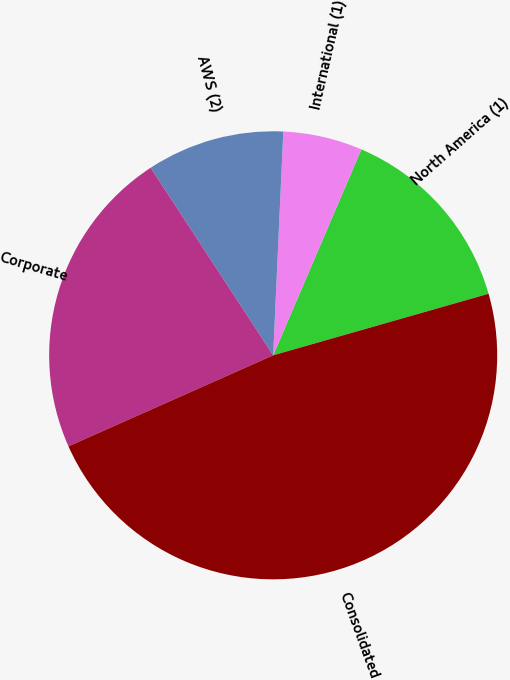Convert chart. <chart><loc_0><loc_0><loc_500><loc_500><pie_chart><fcel>North America (1)<fcel>International (1)<fcel>AWS (2)<fcel>Corporate<fcel>Consolidated<nl><fcel>14.13%<fcel>5.72%<fcel>9.93%<fcel>22.45%<fcel>47.77%<nl></chart> 